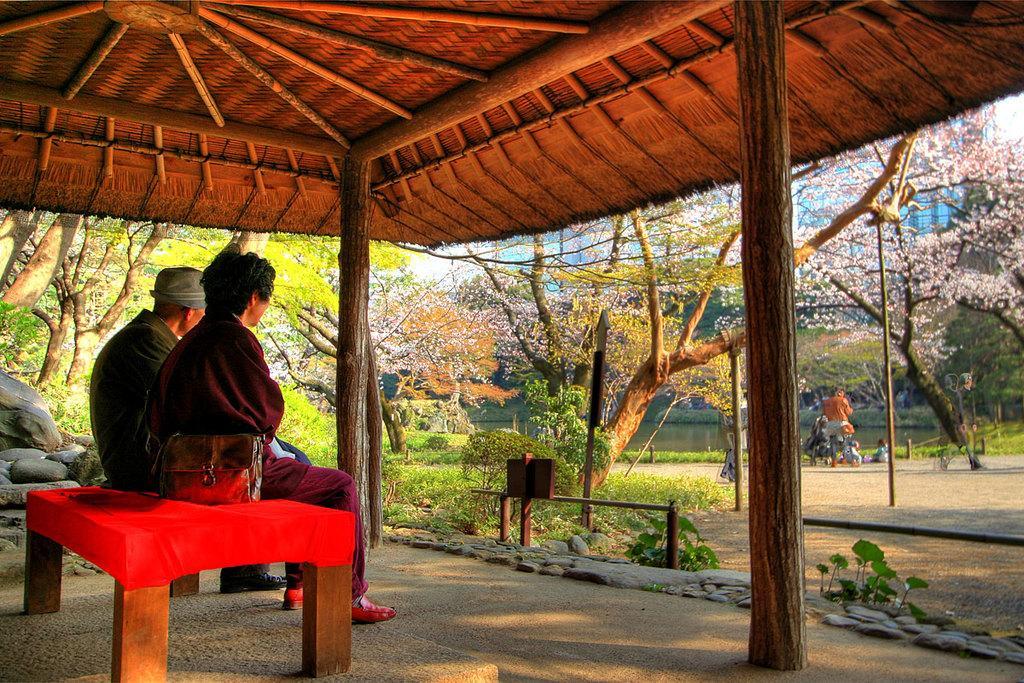Describe this image in one or two sentences. In the picture, there are two people sitting on the sofa, far away from them a person is standing they are sitting under a hut , there are lot of trees, bushes and grass in the background there is a sky. 